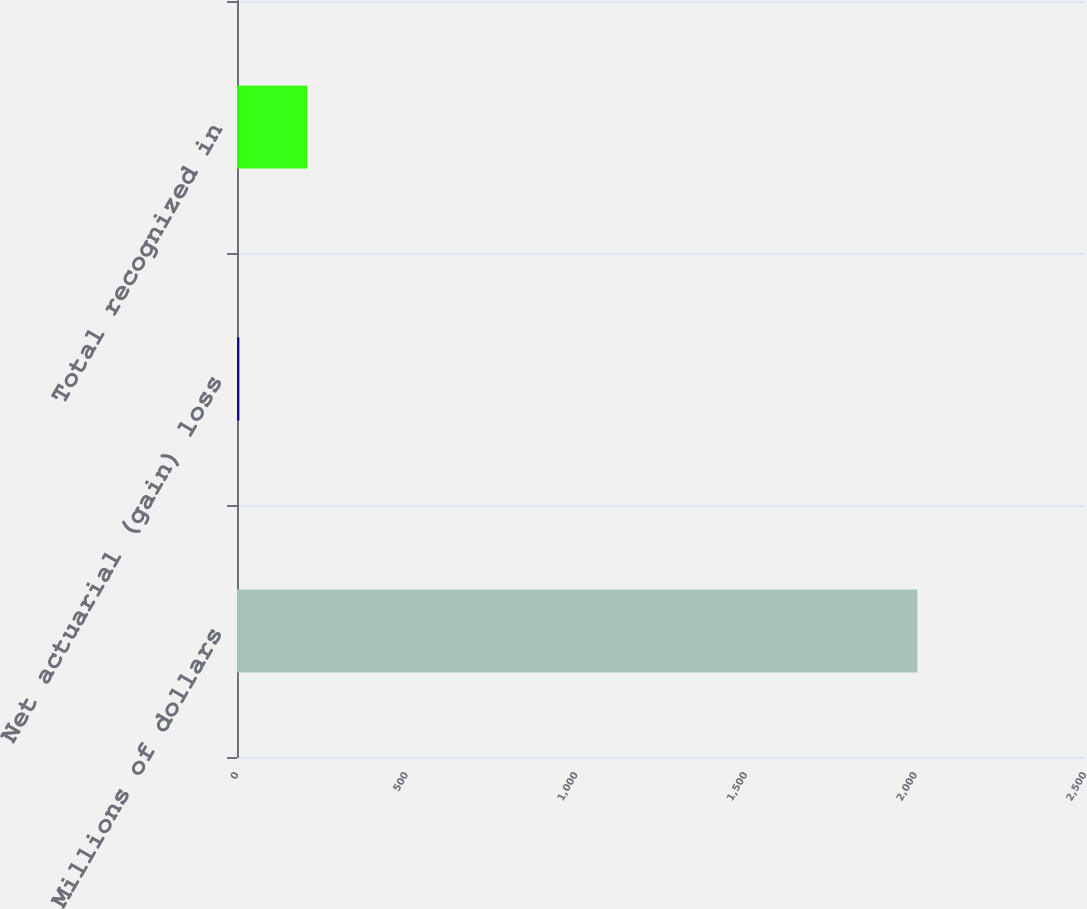Convert chart to OTSL. <chart><loc_0><loc_0><loc_500><loc_500><bar_chart><fcel>Millions of dollars<fcel>Net actuarial (gain) loss<fcel>Total recognized in<nl><fcel>2006<fcel>7<fcel>206.9<nl></chart> 